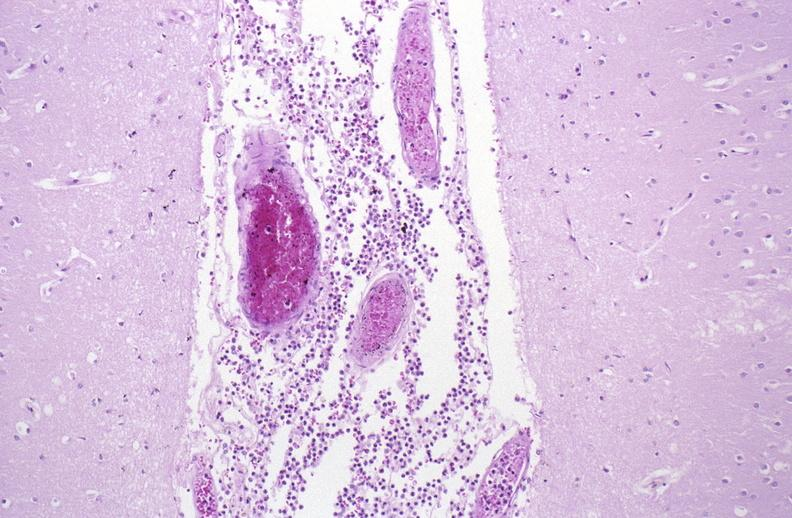what is present?
Answer the question using a single word or phrase. Nervous 